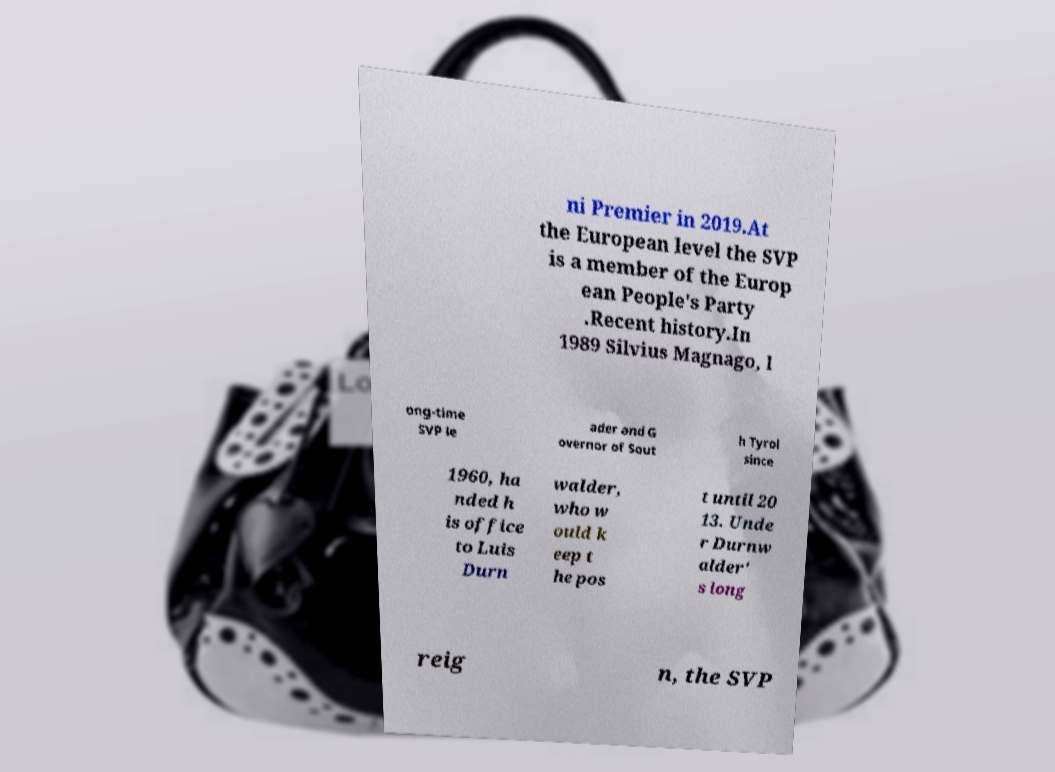Could you extract and type out the text from this image? ni Premier in 2019.At the European level the SVP is a member of the Europ ean People's Party .Recent history.In 1989 Silvius Magnago, l ong-time SVP le ader and G overnor of Sout h Tyrol since 1960, ha nded h is office to Luis Durn walder, who w ould k eep t he pos t until 20 13. Unde r Durnw alder' s long reig n, the SVP 